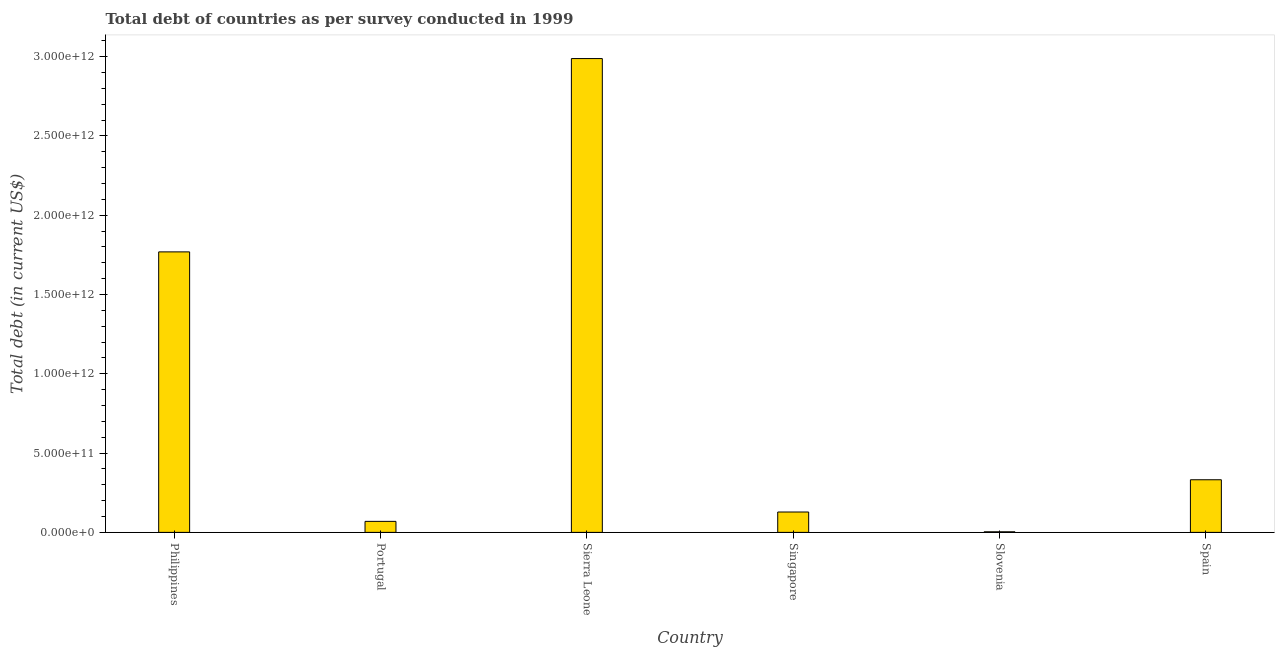Does the graph contain any zero values?
Your answer should be very brief. No. What is the title of the graph?
Offer a terse response. Total debt of countries as per survey conducted in 1999. What is the label or title of the Y-axis?
Offer a very short reply. Total debt (in current US$). What is the total debt in Singapore?
Provide a short and direct response. 1.28e+11. Across all countries, what is the maximum total debt?
Provide a succinct answer. 2.99e+12. Across all countries, what is the minimum total debt?
Provide a succinct answer. 3.73e+09. In which country was the total debt maximum?
Keep it short and to the point. Sierra Leone. In which country was the total debt minimum?
Your response must be concise. Slovenia. What is the sum of the total debt?
Provide a short and direct response. 5.29e+12. What is the difference between the total debt in Philippines and Spain?
Make the answer very short. 1.44e+12. What is the average total debt per country?
Offer a very short reply. 8.82e+11. What is the median total debt?
Ensure brevity in your answer.  2.30e+11. What is the ratio of the total debt in Sierra Leone to that in Singapore?
Provide a short and direct response. 23.25. Is the total debt in Portugal less than that in Singapore?
Provide a short and direct response. Yes. What is the difference between the highest and the second highest total debt?
Provide a short and direct response. 1.22e+12. What is the difference between the highest and the lowest total debt?
Provide a short and direct response. 2.98e+12. How many bars are there?
Provide a short and direct response. 6. Are all the bars in the graph horizontal?
Keep it short and to the point. No. How many countries are there in the graph?
Ensure brevity in your answer.  6. What is the difference between two consecutive major ticks on the Y-axis?
Ensure brevity in your answer.  5.00e+11. Are the values on the major ticks of Y-axis written in scientific E-notation?
Your answer should be very brief. Yes. What is the Total debt (in current US$) of Philippines?
Provide a succinct answer. 1.77e+12. What is the Total debt (in current US$) of Portugal?
Offer a terse response. 6.95e+1. What is the Total debt (in current US$) in Sierra Leone?
Your response must be concise. 2.99e+12. What is the Total debt (in current US$) in Singapore?
Make the answer very short. 1.28e+11. What is the Total debt (in current US$) in Slovenia?
Provide a succinct answer. 3.73e+09. What is the Total debt (in current US$) in Spain?
Provide a succinct answer. 3.32e+11. What is the difference between the Total debt (in current US$) in Philippines and Portugal?
Offer a very short reply. 1.70e+12. What is the difference between the Total debt (in current US$) in Philippines and Sierra Leone?
Provide a short and direct response. -1.22e+12. What is the difference between the Total debt (in current US$) in Philippines and Singapore?
Your answer should be compact. 1.64e+12. What is the difference between the Total debt (in current US$) in Philippines and Slovenia?
Ensure brevity in your answer.  1.76e+12. What is the difference between the Total debt (in current US$) in Philippines and Spain?
Keep it short and to the point. 1.44e+12. What is the difference between the Total debt (in current US$) in Portugal and Sierra Leone?
Offer a terse response. -2.92e+12. What is the difference between the Total debt (in current US$) in Portugal and Singapore?
Provide a succinct answer. -5.90e+1. What is the difference between the Total debt (in current US$) in Portugal and Slovenia?
Your response must be concise. 6.57e+1. What is the difference between the Total debt (in current US$) in Portugal and Spain?
Ensure brevity in your answer.  -2.62e+11. What is the difference between the Total debt (in current US$) in Sierra Leone and Singapore?
Your answer should be very brief. 2.86e+12. What is the difference between the Total debt (in current US$) in Sierra Leone and Slovenia?
Provide a short and direct response. 2.98e+12. What is the difference between the Total debt (in current US$) in Sierra Leone and Spain?
Ensure brevity in your answer.  2.66e+12. What is the difference between the Total debt (in current US$) in Singapore and Slovenia?
Make the answer very short. 1.25e+11. What is the difference between the Total debt (in current US$) in Singapore and Spain?
Your response must be concise. -2.03e+11. What is the difference between the Total debt (in current US$) in Slovenia and Spain?
Keep it short and to the point. -3.28e+11. What is the ratio of the Total debt (in current US$) in Philippines to that in Portugal?
Your response must be concise. 25.46. What is the ratio of the Total debt (in current US$) in Philippines to that in Sierra Leone?
Ensure brevity in your answer.  0.59. What is the ratio of the Total debt (in current US$) in Philippines to that in Singapore?
Provide a short and direct response. 13.76. What is the ratio of the Total debt (in current US$) in Philippines to that in Slovenia?
Your answer should be compact. 474.48. What is the ratio of the Total debt (in current US$) in Philippines to that in Spain?
Your response must be concise. 5.33. What is the ratio of the Total debt (in current US$) in Portugal to that in Sierra Leone?
Offer a terse response. 0.02. What is the ratio of the Total debt (in current US$) in Portugal to that in Singapore?
Offer a very short reply. 0.54. What is the ratio of the Total debt (in current US$) in Portugal to that in Slovenia?
Your answer should be very brief. 18.64. What is the ratio of the Total debt (in current US$) in Portugal to that in Spain?
Provide a succinct answer. 0.21. What is the ratio of the Total debt (in current US$) in Sierra Leone to that in Singapore?
Your response must be concise. 23.25. What is the ratio of the Total debt (in current US$) in Sierra Leone to that in Slovenia?
Your answer should be very brief. 801.47. What is the ratio of the Total debt (in current US$) in Sierra Leone to that in Spain?
Offer a very short reply. 9. What is the ratio of the Total debt (in current US$) in Singapore to that in Slovenia?
Give a very brief answer. 34.47. What is the ratio of the Total debt (in current US$) in Singapore to that in Spain?
Provide a short and direct response. 0.39. What is the ratio of the Total debt (in current US$) in Slovenia to that in Spain?
Give a very brief answer. 0.01. 